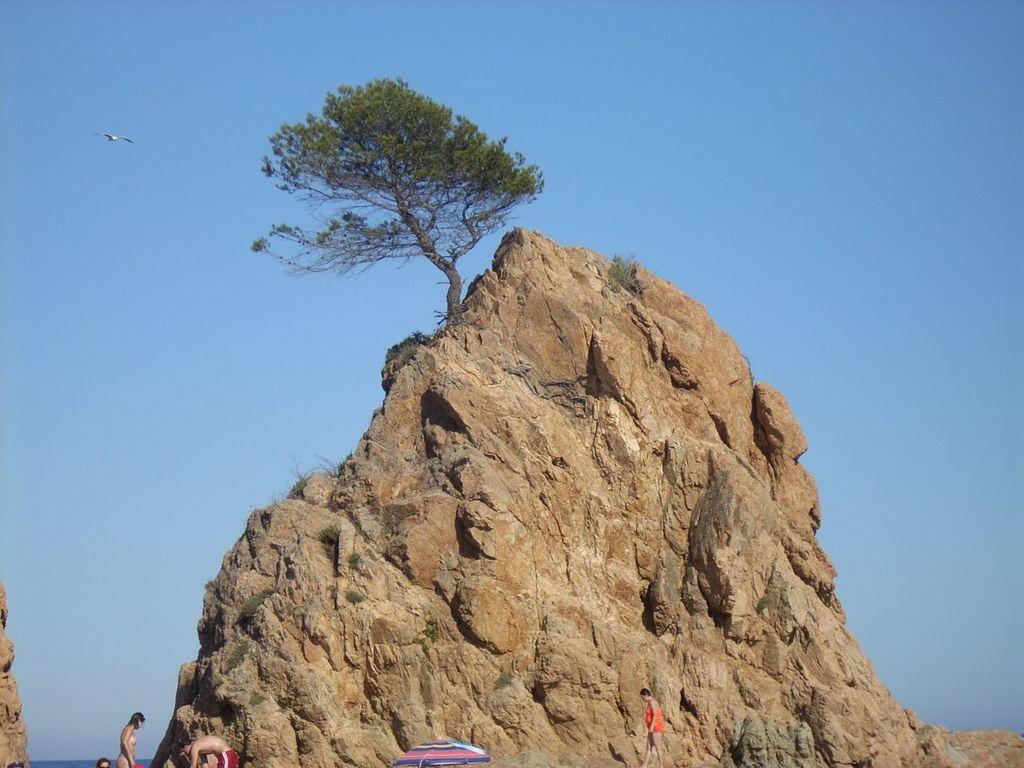What is the main feature in the image? There is a big rock in the image. What is on top of the rock? There is a tree on the rock. Where are the people located in the image? The people are on the left side of the image. What is visible at the top of the image? The sky is visible at the top of the image. What type of pan is being used to cook food on the rock? There is no pan or cooking activity present in the image. What thoughts are the people having while standing on the left side of the image? There is no information about the thoughts of the people in the image. 